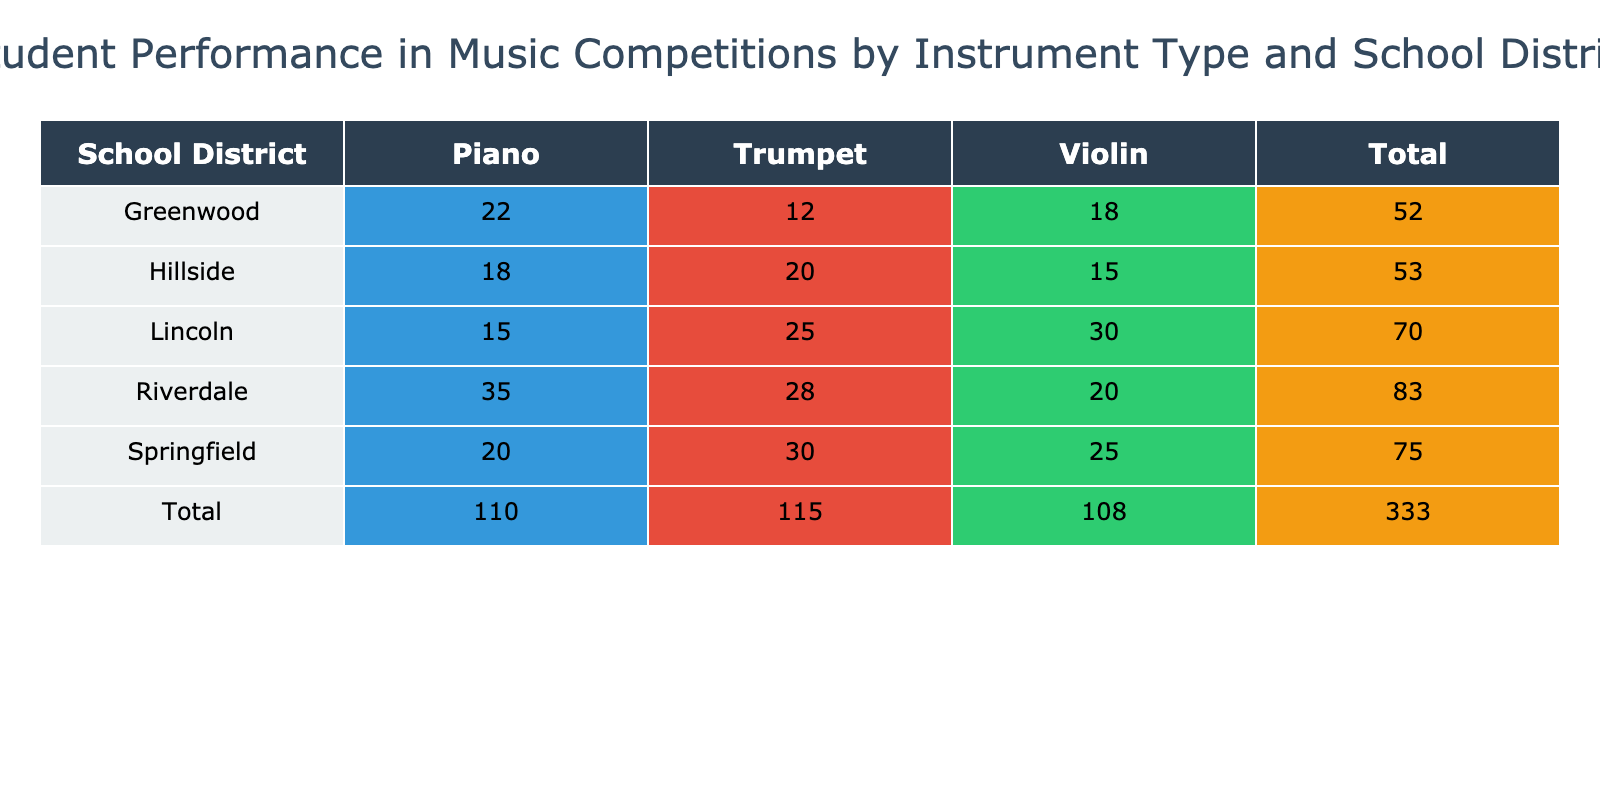What is the total number of students participating in music competitions from the Lincoln school district? Looking at the Lincoln row, the number of students for each instrument type is Violin (30), Trumpet (25), and Piano (15). Adding these values gives us a total: 30 + 25 + 15 = 70.
Answer: 70 Which instrument type has the highest average score in the Springfield school district? In the Springfield row, the average scores for each instrument type are Violin (86.5), Trumpet (82.0), and Piano (90.1). The highest among these is the Piano with an average score of 90.1.
Answer: Piano Is there a school district where students performed better on the Violin compared to the Trumpet? Yes, if we compare the average scores, in Springfield the Violin score is 86.5 and the Trumpet score is 82.0. In Lincoln, the Violin score is 91.2 and the Trumpet score is 87.4. Both Springfield and Lincoln show higher scores for Violin compared to Trumpet.
Answer: Yes What is the difference in the total number of students between the Greenwood and Riverdale school districts? For Greenwood, the total number of students is Violin (18) + Trumpet (12) + Piano (22) = 52. For Riverdale, the total is Violin (20) + Trumpet (28) + Piano (35) = 83. The difference is 83 - 52 = 31.
Answer: 31 Which school district has the least number of students participating in music competitions? By calculating the total for each district: Springfield (85), Greenwood (52), Lincoln (70), Riverdale (83), and Hillside (53). The smallest total is from Greenwood with 52 students.
Answer: Greenwood In how many districts do students perform better on the Piano than the average score of 85? The average scores for Piano are Springfield (90.1), Greenwood (88.0), Riverdale (90.5), and Lincoln (85.6). Springfield, Greenwood, and Riverdale all have scores above 85, making it three districts where students perform better on Piano.
Answer: 3 What percentage of the total students from Hillside play the Violin? The total number of students from Hillside is Violin (15) + Trumpet (20) + Piano (18) = 53. The number of students playing Violin is 15. To find the percentage, (15 / 53) * 100 = 28.30%.
Answer: 28.30% Do more students from Springfield play Trumpet or Violin? In Springfield, 30 students play Trumpet and 25 students play Violin. Since 30 is greater than 25, more students participate in Trumpet.
Answer: Trumpet What is the average score for all the instruments in the Riverdale district? For Riverdale, the average scores are Violin (83.5), Trumpet (81.2), and Piano (90.5). The average score across these three is (83.5 + 81.2 + 90.5) / 3 = 85.07.
Answer: 85.07 